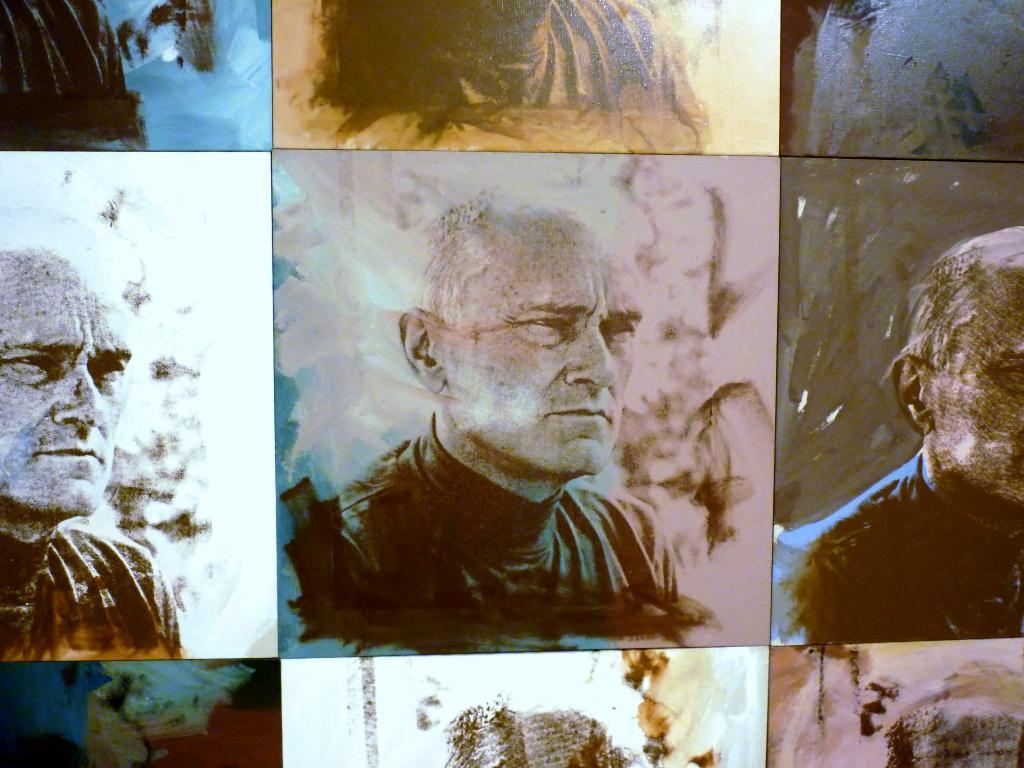What type of artwork is depicted in the image? There are collage frames in the image. What is featured in each frame? In each frame, there is a man. What is the man wearing in the image? The man is wearing a black dress in each frame. How do the backgrounds of the frames differ from one another? The background of each frame has different colors. What type of sweater is the man wearing in the image? The man is not wearing a sweater in the image; he is wearing a black dress. Can you tell me how many mint leaves are in the image? There are no mint leaves present in the image. 